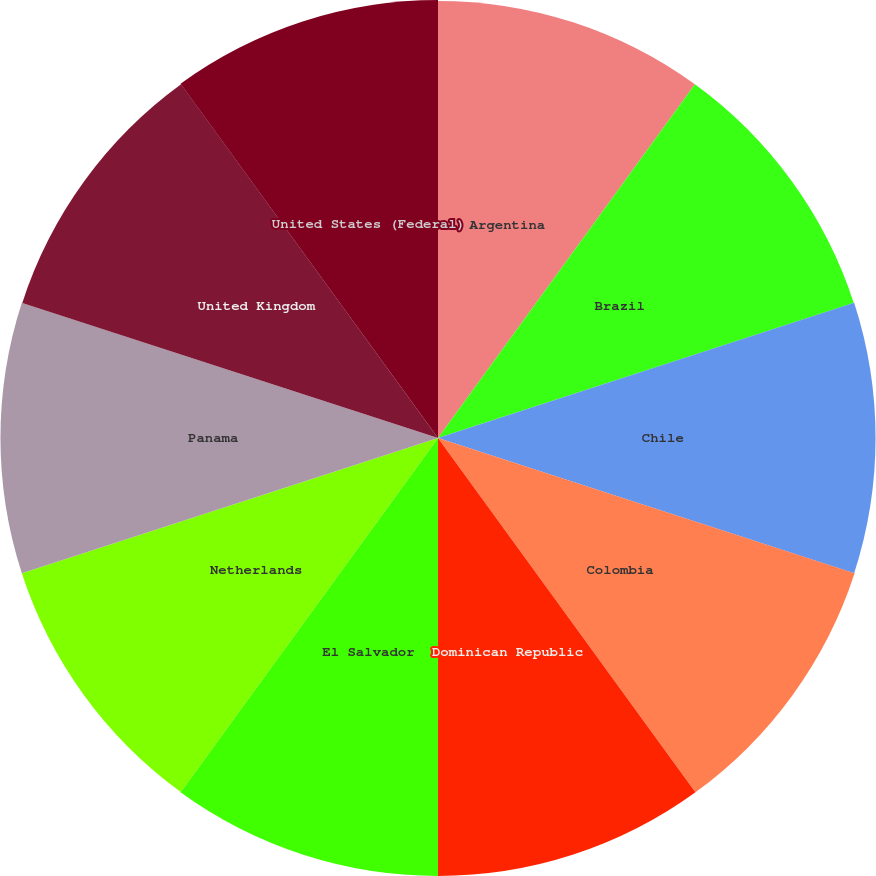<chart> <loc_0><loc_0><loc_500><loc_500><pie_chart><fcel>Argentina<fcel>Brazil<fcel>Chile<fcel>Colombia<fcel>Dominican Republic<fcel>El Salvador<fcel>Netherlands<fcel>Panama<fcel>United Kingdom<fcel>United States (Federal)<nl><fcel>9.99%<fcel>9.99%<fcel>10.0%<fcel>10.01%<fcel>10.01%<fcel>10.01%<fcel>10.0%<fcel>10.0%<fcel>9.99%<fcel>10.01%<nl></chart> 